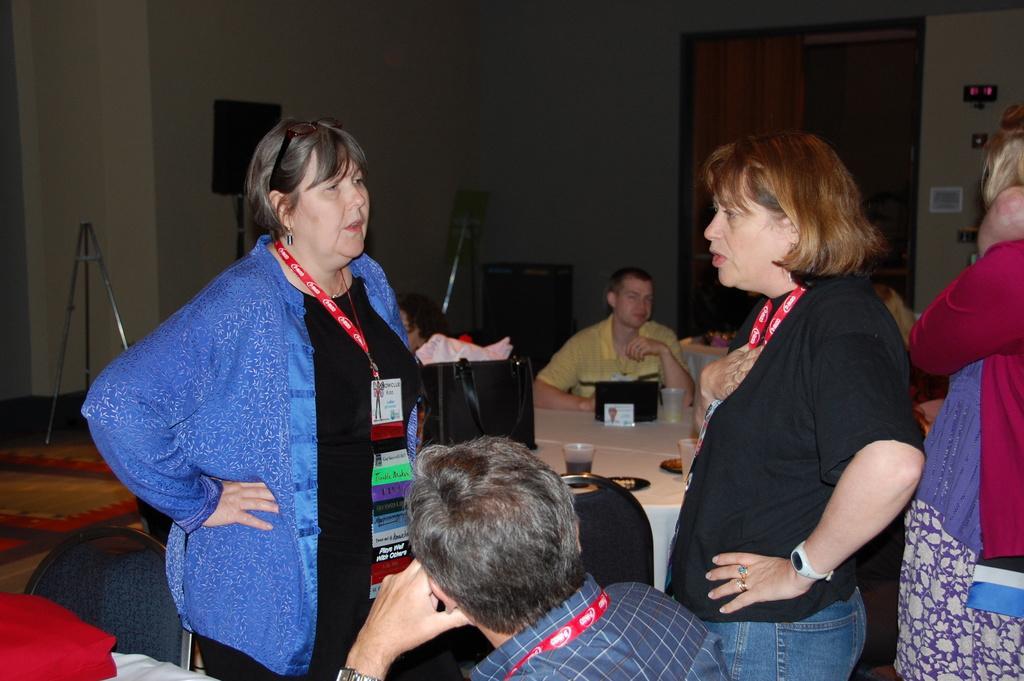How would you summarize this image in a sentence or two? On left corner of this picture, we see women wearing blue shirt and black t-shirt. She is talking to the other woman standing opposite side, she is wearing id card and the woman on the opposite side is wearing black color shirt and watch. She is also talking to the woman on the other side. In front the man sitting on the chair is watching both of them. Here we have chairs and tables on which we can find glass, plates, laptops. Behind them, we see man sitting on a chair with yellow t-shirt. behind them we see door and door curtain, we even see stand on the left of the picture. 